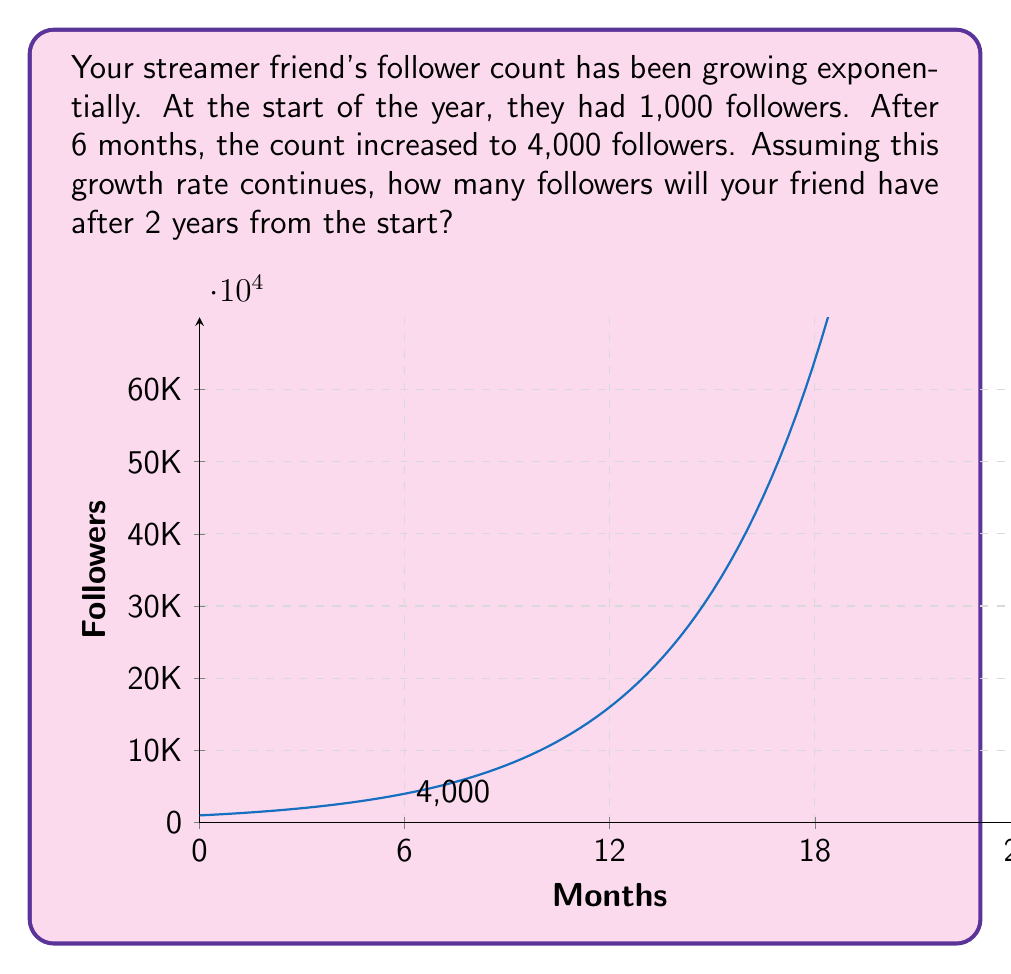Give your solution to this math problem. Let's approach this step-by-step:

1) We can model this growth with an exponential function of the form:
   $$ f(t) = 1000 \cdot e^{rt} $$
   where $f(t)$ is the number of followers at time $t$ (in months), and $r$ is the growth rate.

2) We know that after 6 months ($t=6$), the follower count is 4,000. Let's use this to find $r$:
   $$ 4000 = 1000 \cdot e^{6r} $$

3) Dividing both sides by 1000:
   $$ 4 = e^{6r} $$

4) Taking the natural log of both sides:
   $$ \ln(4) = 6r $$

5) Solving for $r$:
   $$ r = \frac{\ln(4)}{6} \approx 0.2310585 $$

6) Now that we have $r$, we can use the original function to find the follower count after 2 years (24 months):
   $$ f(24) = 1000 \cdot e^{0.2310585 \cdot 24} $$

7) Calculating this:
   $$ f(24) = 1000 \cdot e^{5.54540441} \approx 256,000 $$

Therefore, after 2 years, your streamer friend will have approximately 256,000 followers if the growth rate remains constant.
Answer: 256,000 followers 